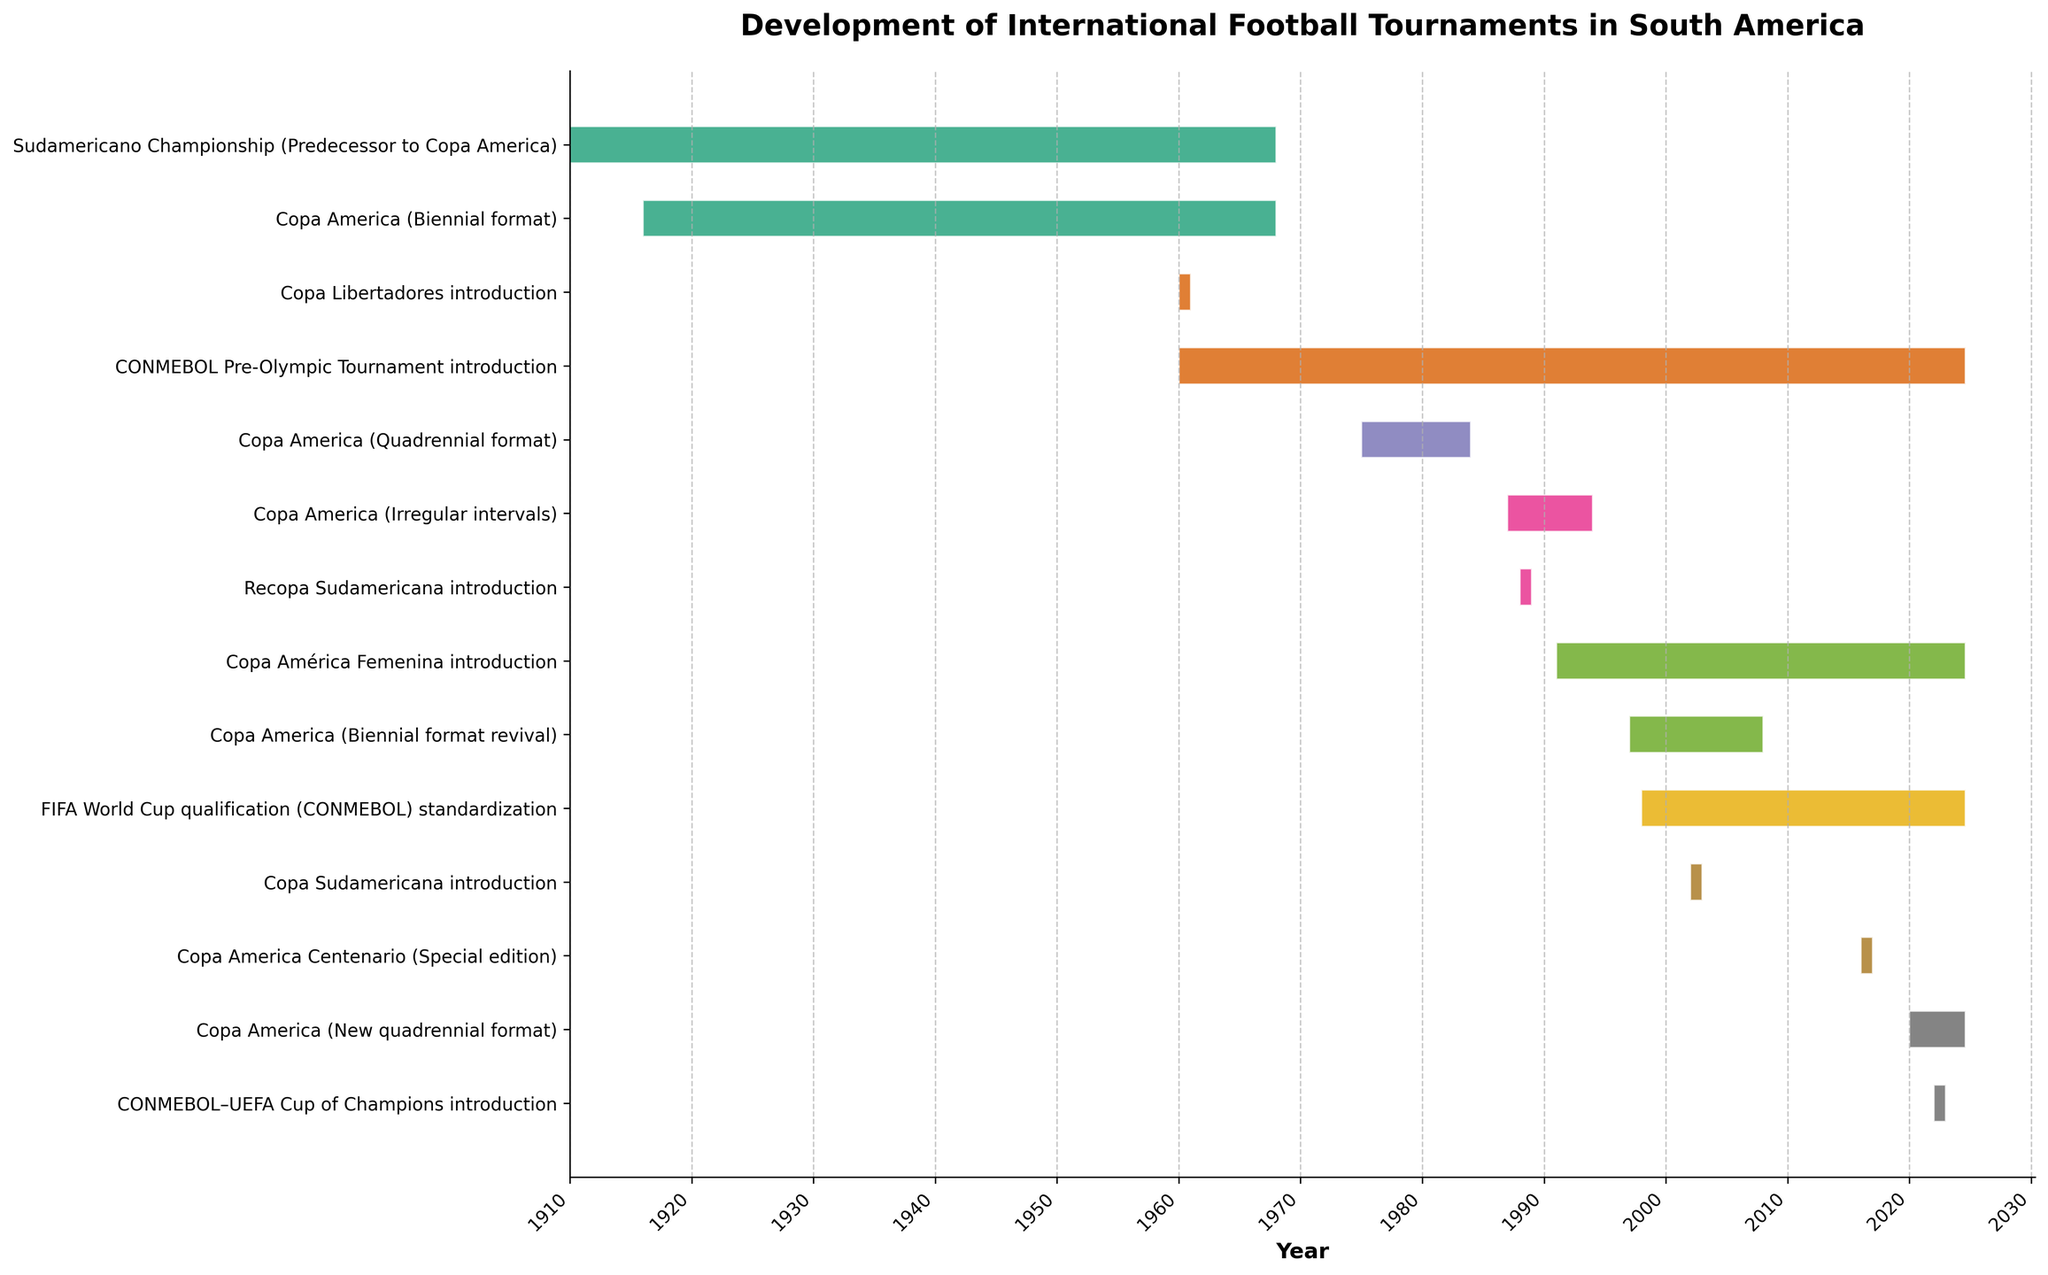How many times has the format of Copa America changed throughout its history? By examining the Gantt chart, the Copa America format changes are labelled: Biennial format (1916-1967), Quadrennial format (1975-1983), Irregular intervals (1987-1993), Biennial format revival (1997-2007), and New quadrennial format (2020-Present). Counting these changes gives a total of 5.
Answer: 5 What is the total duration of Copa América Femenina’s existence shown in the chart? The chart shows that Copa América Femenina started in 1991 and continues to the present. Since the present year is 2023, the total duration is 2023 - 1991 = 32 years.
Answer: 32 years Which was introduced first: Copa Libertadores or Recopa Sudamericana? By referring to the timeline on the Gantt chart, Copa Libertadores was introduced in 1960, while Recopa Sudamericana was introduced in 1988. Since 1960 is earlier than 1988, Copa Libertadores was introduced first.
Answer: Copa Libertadores How long did the Sudamericano Championship last before being replaced by Copa America? The Gantt chart indicates that the Sudamericano Championship lasted from 1910 to 1967. This gives a duration of 1967 - 1910 = 57 years.
Answer: 57 years How many special editions of Copa America are shown on the chart? The chart shows a single special edition of Copa America, labeled as Copa America Centenario in 2016.
Answer: 1 Which international football tournament has the longest continuous existence according to the chart? By comparing the duration bars on the Gantt chart, the "FIFA World Cup qualification (CONMEBOL)" standardization, starting from 1998 to the present, has a long continuous timeline. However, "Copa Libertadores introduction" from 1960 to the present spans the longest period.
Answer: Copa Libertadores What is the gap between the end of the Copa America Biennial format in 1967 and the start of the Quadrennial format in 1975? The Gantt chart shows the end of the Biennial format in 1967 and the start of the Quadrennial format in 1975. The gap between 1967 and 1975 is 1975 - 1967 = 8 years.
Answer: 8 years What unique feature distinguishes the Copa America Centenario in the chart? The Gantt chart identifies the Copa America Centenario as a special edition that lasted only for a single year, 2016, unlike other formats which span multiple years.
Answer: Special edition for one year 